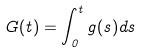<formula> <loc_0><loc_0><loc_500><loc_500>G ( t ) = \int _ { 0 } ^ { t } g ( s ) d s</formula> 